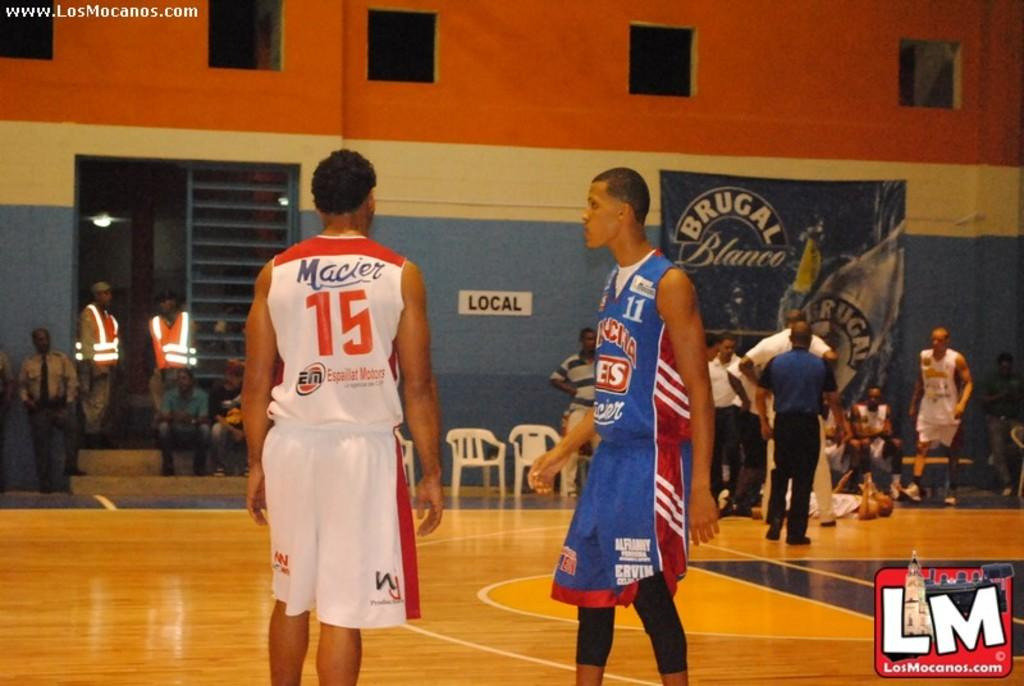<image>
Describe the image concisely. players stand in foreground while in the back others attend to fallen player in image stamped with www.losmocanos.com 